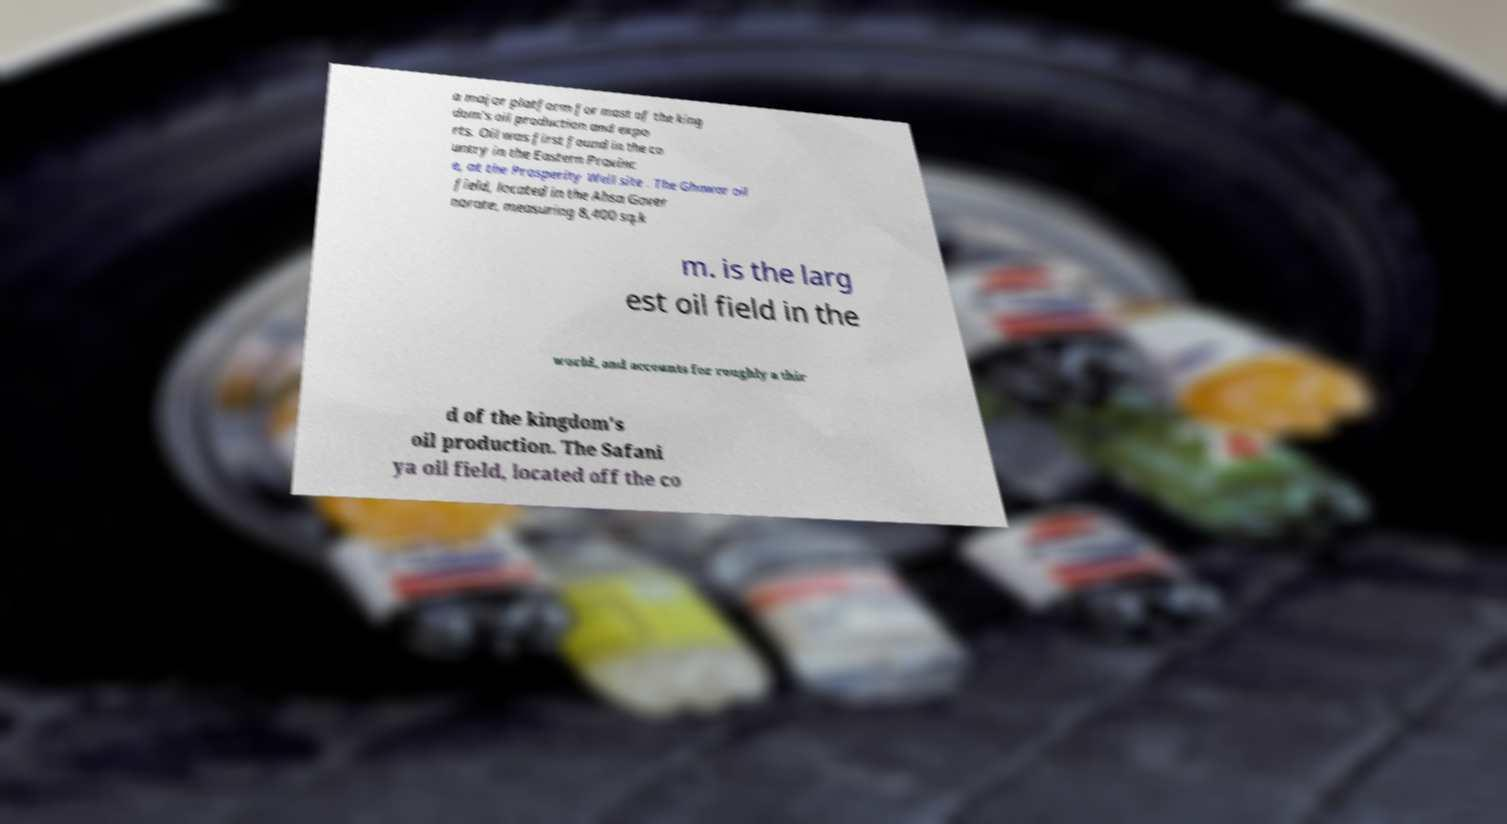Please read and relay the text visible in this image. What does it say? a major platform for most of the king dom's oil production and expo rts. Oil was first found in the co untry in the Eastern Provinc e, at the Prosperity Well site . The Ghawar oil field, located in the Ahsa Gover norate, measuring 8,400 sq.k m. is the larg est oil field in the world, and accounts for roughly a thir d of the kingdom's oil production. The Safani ya oil field, located off the co 